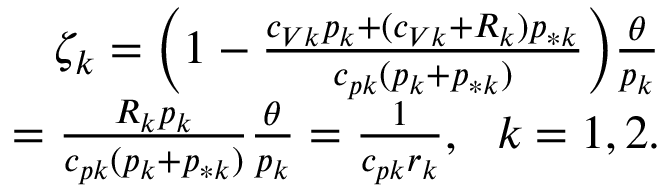Convert formula to latex. <formula><loc_0><loc_0><loc_500><loc_500>\begin{array} { r } { \zeta _ { k } = \left ( 1 - \frac { c _ { V k } p _ { k } + ( c _ { V k } + R _ { k } ) p _ { * k } } { c _ { p k } ( p _ { k } + p _ { * k } ) } \right ) \frac { \theta } { p _ { k } } } \\ { = \frac { R _ { k } p _ { k } } { c _ { p k } ( p _ { k } + p _ { * k } ) } \frac { \theta } { p _ { k } } = \frac { 1 } { c _ { p k } r _ { k } } , \ \ k = 1 , 2 . } \end{array}</formula> 